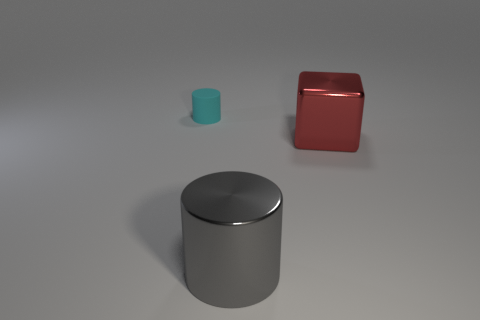Add 3 small green cylinders. How many objects exist? 6 Subtract all cylinders. How many objects are left? 1 Subtract 1 red cubes. How many objects are left? 2 Subtract all large gray cylinders. Subtract all red metal cubes. How many objects are left? 1 Add 3 large cylinders. How many large cylinders are left? 4 Add 2 small matte cylinders. How many small matte cylinders exist? 3 